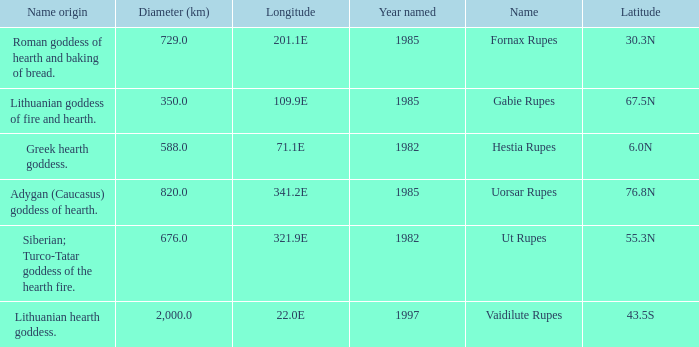At a longitude of 321.9e, what is the latitude of the features found? 55.3N. 